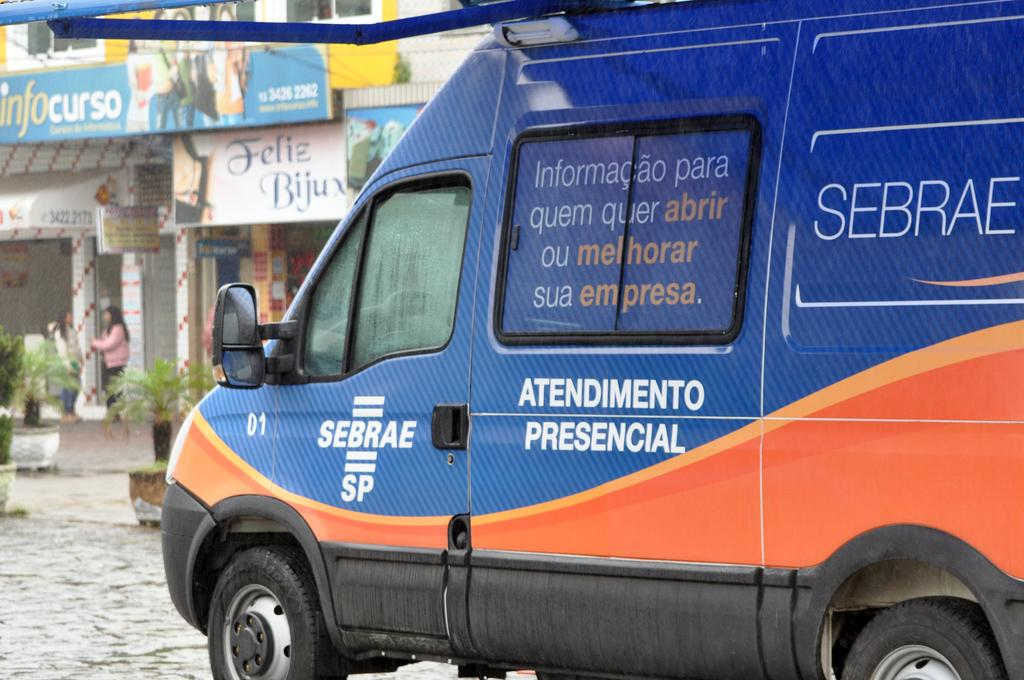<image>
Offer a succinct explanation of the picture presented. A blue and orange van is marked as number 01 near the driver's side window. 